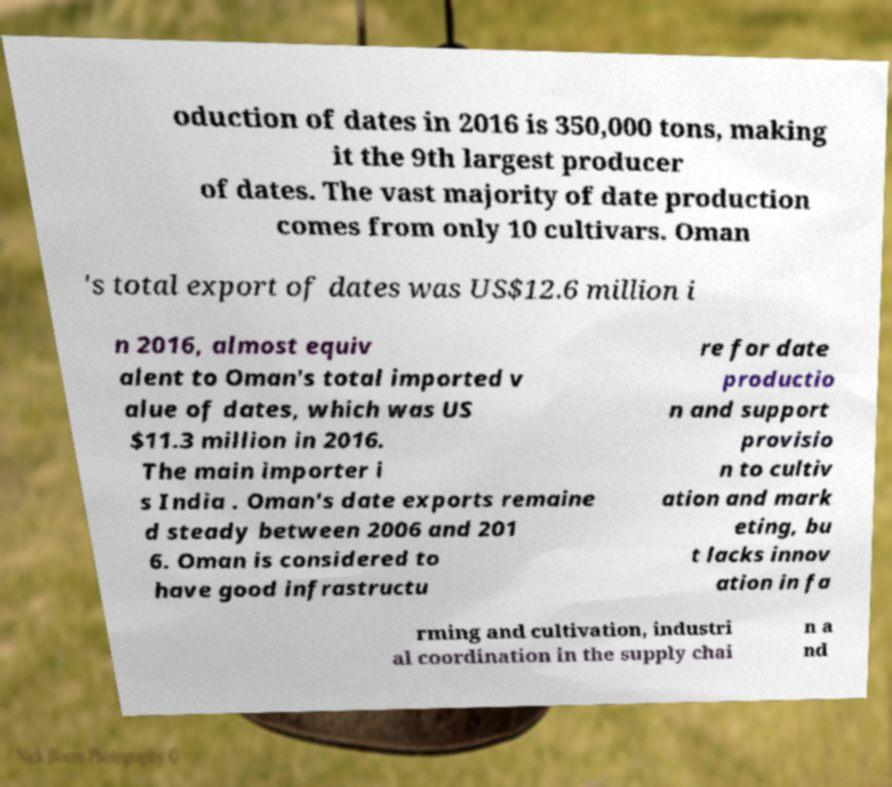Can you read and provide the text displayed in the image?This photo seems to have some interesting text. Can you extract and type it out for me? oduction of dates in 2016 is 350,000 tons, making it the 9th largest producer of dates. The vast majority of date production comes from only 10 cultivars. Oman 's total export of dates was US$12.6 million i n 2016, almost equiv alent to Oman's total imported v alue of dates, which was US $11.3 million in 2016. The main importer i s India . Oman's date exports remaine d steady between 2006 and 201 6. Oman is considered to have good infrastructu re for date productio n and support provisio n to cultiv ation and mark eting, bu t lacks innov ation in fa rming and cultivation, industri al coordination in the supply chai n a nd 